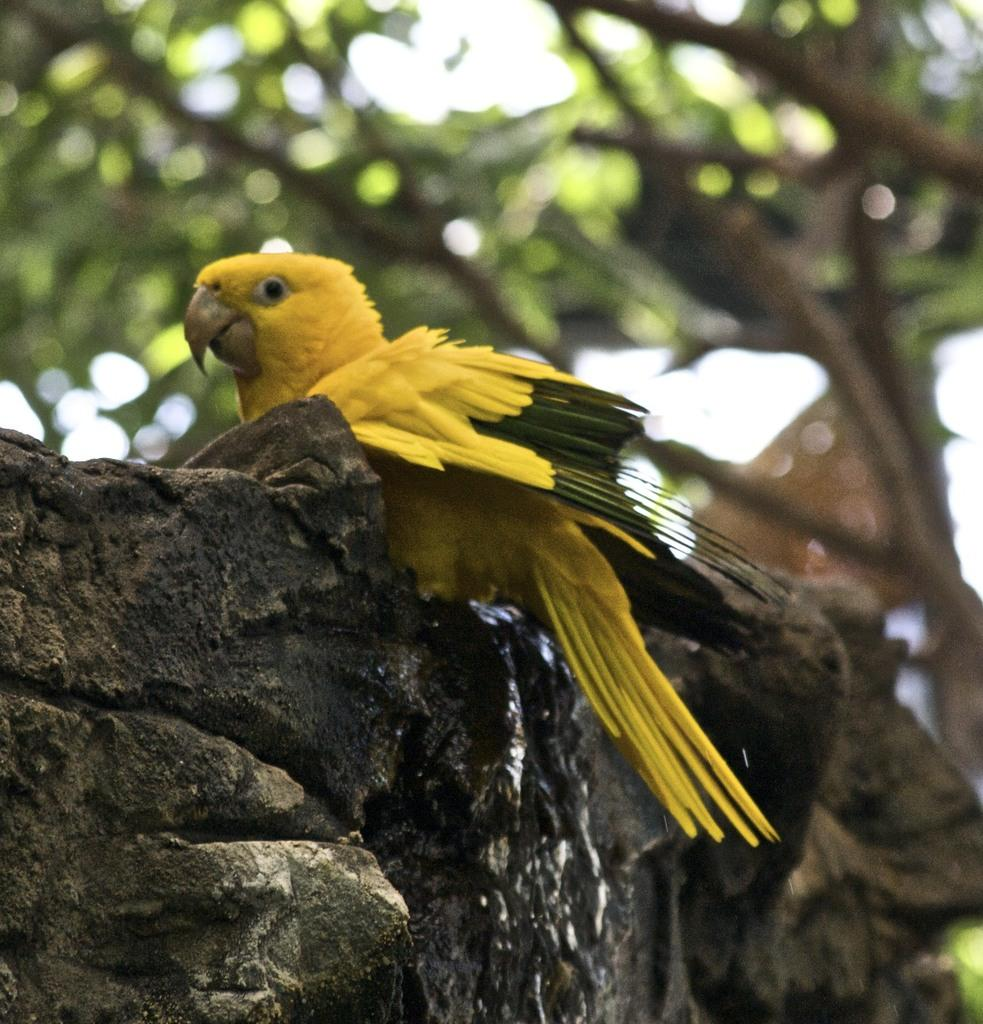What is on the wall in the image? There is a bird on the wall in the image. What can be seen in the background of the image? There are trees visible in the background of the image. What flavor of caption is written on the bird's beak in the image? There is no caption or flavor mentioned in the image; it only features a bird on the wall and trees in the background. 